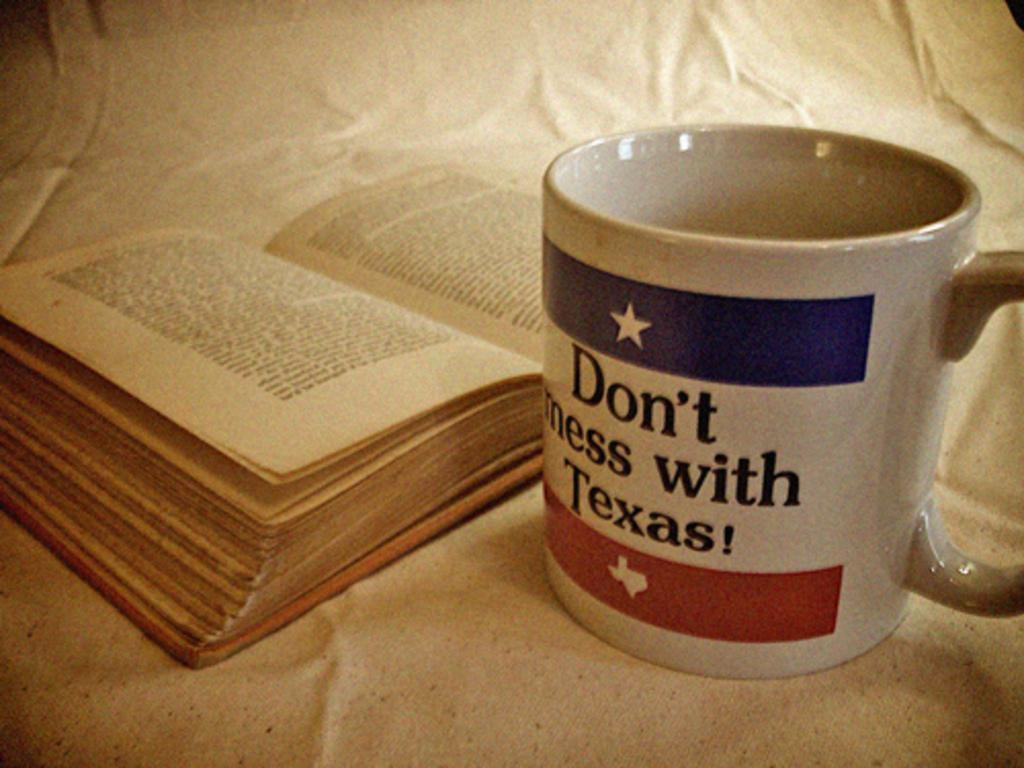What object can be seen in the image that is typically used for reading? There is a book in the image that is typically used for reading. What can be found on the book? There is writing on the book. What is the cup placed on in the image? The cup is placed on a white cloth in the image. What type of song is being sung by the underwear in the image? There is no underwear or singing present in the image. 